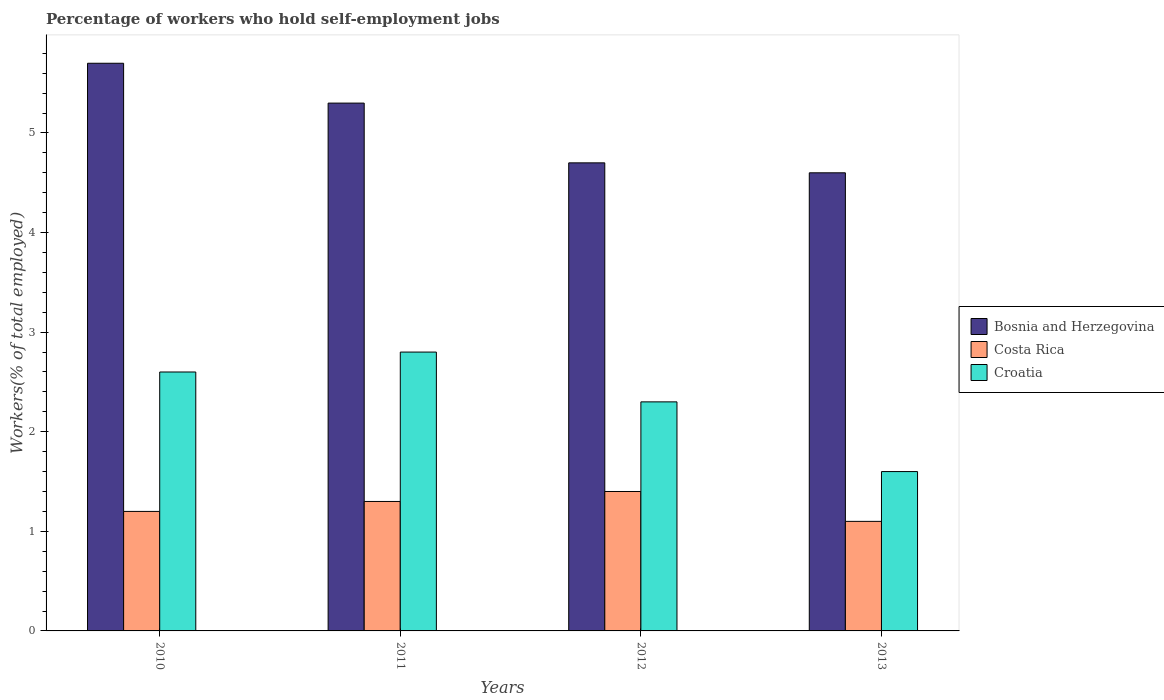How many different coloured bars are there?
Ensure brevity in your answer.  3. Are the number of bars per tick equal to the number of legend labels?
Your response must be concise. Yes. How many bars are there on the 1st tick from the left?
Your answer should be compact. 3. What is the label of the 3rd group of bars from the left?
Keep it short and to the point. 2012. In how many cases, is the number of bars for a given year not equal to the number of legend labels?
Ensure brevity in your answer.  0. What is the percentage of self-employed workers in Bosnia and Herzegovina in 2013?
Give a very brief answer. 4.6. Across all years, what is the maximum percentage of self-employed workers in Croatia?
Make the answer very short. 2.8. Across all years, what is the minimum percentage of self-employed workers in Bosnia and Herzegovina?
Offer a very short reply. 4.6. In which year was the percentage of self-employed workers in Costa Rica maximum?
Keep it short and to the point. 2012. What is the total percentage of self-employed workers in Bosnia and Herzegovina in the graph?
Ensure brevity in your answer.  20.3. What is the difference between the percentage of self-employed workers in Bosnia and Herzegovina in 2010 and that in 2012?
Provide a short and direct response. 1. What is the difference between the percentage of self-employed workers in Bosnia and Herzegovina in 2011 and the percentage of self-employed workers in Croatia in 2013?
Your answer should be very brief. 3.7. What is the average percentage of self-employed workers in Costa Rica per year?
Your answer should be very brief. 1.25. In the year 2011, what is the difference between the percentage of self-employed workers in Croatia and percentage of self-employed workers in Bosnia and Herzegovina?
Offer a very short reply. -2.5. In how many years, is the percentage of self-employed workers in Bosnia and Herzegovina greater than 3 %?
Your response must be concise. 4. What is the ratio of the percentage of self-employed workers in Croatia in 2010 to that in 2013?
Keep it short and to the point. 1.62. Is the difference between the percentage of self-employed workers in Croatia in 2011 and 2012 greater than the difference between the percentage of self-employed workers in Bosnia and Herzegovina in 2011 and 2012?
Your answer should be very brief. No. What is the difference between the highest and the second highest percentage of self-employed workers in Croatia?
Offer a very short reply. 0.2. What is the difference between the highest and the lowest percentage of self-employed workers in Costa Rica?
Keep it short and to the point. 0.3. In how many years, is the percentage of self-employed workers in Croatia greater than the average percentage of self-employed workers in Croatia taken over all years?
Your answer should be compact. 2. Is the sum of the percentage of self-employed workers in Costa Rica in 2011 and 2012 greater than the maximum percentage of self-employed workers in Croatia across all years?
Make the answer very short. No. What does the 3rd bar from the left in 2010 represents?
Your answer should be compact. Croatia. What does the 2nd bar from the right in 2013 represents?
Keep it short and to the point. Costa Rica. How many bars are there?
Your response must be concise. 12. How many years are there in the graph?
Offer a terse response. 4. How are the legend labels stacked?
Your answer should be compact. Vertical. What is the title of the graph?
Make the answer very short. Percentage of workers who hold self-employment jobs. Does "Dominica" appear as one of the legend labels in the graph?
Your response must be concise. No. What is the label or title of the Y-axis?
Give a very brief answer. Workers(% of total employed). What is the Workers(% of total employed) in Bosnia and Herzegovina in 2010?
Offer a very short reply. 5.7. What is the Workers(% of total employed) in Costa Rica in 2010?
Offer a very short reply. 1.2. What is the Workers(% of total employed) in Croatia in 2010?
Ensure brevity in your answer.  2.6. What is the Workers(% of total employed) of Bosnia and Herzegovina in 2011?
Give a very brief answer. 5.3. What is the Workers(% of total employed) of Costa Rica in 2011?
Ensure brevity in your answer.  1.3. What is the Workers(% of total employed) of Croatia in 2011?
Give a very brief answer. 2.8. What is the Workers(% of total employed) of Bosnia and Herzegovina in 2012?
Your response must be concise. 4.7. What is the Workers(% of total employed) of Costa Rica in 2012?
Provide a short and direct response. 1.4. What is the Workers(% of total employed) in Croatia in 2012?
Ensure brevity in your answer.  2.3. What is the Workers(% of total employed) in Bosnia and Herzegovina in 2013?
Offer a terse response. 4.6. What is the Workers(% of total employed) in Costa Rica in 2013?
Offer a very short reply. 1.1. What is the Workers(% of total employed) in Croatia in 2013?
Your answer should be compact. 1.6. Across all years, what is the maximum Workers(% of total employed) in Bosnia and Herzegovina?
Your answer should be compact. 5.7. Across all years, what is the maximum Workers(% of total employed) of Costa Rica?
Your answer should be compact. 1.4. Across all years, what is the maximum Workers(% of total employed) in Croatia?
Keep it short and to the point. 2.8. Across all years, what is the minimum Workers(% of total employed) of Bosnia and Herzegovina?
Offer a terse response. 4.6. Across all years, what is the minimum Workers(% of total employed) of Costa Rica?
Keep it short and to the point. 1.1. Across all years, what is the minimum Workers(% of total employed) of Croatia?
Offer a terse response. 1.6. What is the total Workers(% of total employed) of Bosnia and Herzegovina in the graph?
Your response must be concise. 20.3. What is the difference between the Workers(% of total employed) in Bosnia and Herzegovina in 2010 and that in 2011?
Keep it short and to the point. 0.4. What is the difference between the Workers(% of total employed) of Costa Rica in 2010 and that in 2011?
Offer a very short reply. -0.1. What is the difference between the Workers(% of total employed) of Croatia in 2010 and that in 2011?
Provide a succinct answer. -0.2. What is the difference between the Workers(% of total employed) in Bosnia and Herzegovina in 2010 and that in 2012?
Make the answer very short. 1. What is the difference between the Workers(% of total employed) of Croatia in 2010 and that in 2012?
Provide a succinct answer. 0.3. What is the difference between the Workers(% of total employed) of Costa Rica in 2010 and that in 2013?
Offer a terse response. 0.1. What is the difference between the Workers(% of total employed) of Croatia in 2010 and that in 2013?
Your response must be concise. 1. What is the difference between the Workers(% of total employed) in Bosnia and Herzegovina in 2011 and that in 2013?
Your response must be concise. 0.7. What is the difference between the Workers(% of total employed) in Costa Rica in 2011 and that in 2013?
Ensure brevity in your answer.  0.2. What is the difference between the Workers(% of total employed) in Bosnia and Herzegovina in 2012 and that in 2013?
Your answer should be compact. 0.1. What is the difference between the Workers(% of total employed) in Croatia in 2012 and that in 2013?
Your response must be concise. 0.7. What is the difference between the Workers(% of total employed) of Bosnia and Herzegovina in 2010 and the Workers(% of total employed) of Croatia in 2011?
Keep it short and to the point. 2.9. What is the difference between the Workers(% of total employed) of Costa Rica in 2010 and the Workers(% of total employed) of Croatia in 2011?
Give a very brief answer. -1.6. What is the difference between the Workers(% of total employed) of Bosnia and Herzegovina in 2010 and the Workers(% of total employed) of Costa Rica in 2013?
Your response must be concise. 4.6. What is the difference between the Workers(% of total employed) in Bosnia and Herzegovina in 2010 and the Workers(% of total employed) in Croatia in 2013?
Offer a terse response. 4.1. What is the difference between the Workers(% of total employed) in Bosnia and Herzegovina in 2011 and the Workers(% of total employed) in Croatia in 2012?
Offer a very short reply. 3. What is the difference between the Workers(% of total employed) in Costa Rica in 2011 and the Workers(% of total employed) in Croatia in 2013?
Your answer should be very brief. -0.3. What is the difference between the Workers(% of total employed) of Bosnia and Herzegovina in 2012 and the Workers(% of total employed) of Costa Rica in 2013?
Provide a short and direct response. 3.6. What is the difference between the Workers(% of total employed) of Costa Rica in 2012 and the Workers(% of total employed) of Croatia in 2013?
Make the answer very short. -0.2. What is the average Workers(% of total employed) in Bosnia and Herzegovina per year?
Provide a short and direct response. 5.08. What is the average Workers(% of total employed) of Croatia per year?
Make the answer very short. 2.33. In the year 2011, what is the difference between the Workers(% of total employed) of Bosnia and Herzegovina and Workers(% of total employed) of Costa Rica?
Keep it short and to the point. 4. In the year 2011, what is the difference between the Workers(% of total employed) in Bosnia and Herzegovina and Workers(% of total employed) in Croatia?
Make the answer very short. 2.5. In the year 2012, what is the difference between the Workers(% of total employed) of Bosnia and Herzegovina and Workers(% of total employed) of Costa Rica?
Your answer should be very brief. 3.3. In the year 2012, what is the difference between the Workers(% of total employed) in Bosnia and Herzegovina and Workers(% of total employed) in Croatia?
Provide a succinct answer. 2.4. In the year 2012, what is the difference between the Workers(% of total employed) of Costa Rica and Workers(% of total employed) of Croatia?
Your answer should be very brief. -0.9. In the year 2013, what is the difference between the Workers(% of total employed) of Bosnia and Herzegovina and Workers(% of total employed) of Croatia?
Keep it short and to the point. 3. In the year 2013, what is the difference between the Workers(% of total employed) of Costa Rica and Workers(% of total employed) of Croatia?
Your answer should be very brief. -0.5. What is the ratio of the Workers(% of total employed) of Bosnia and Herzegovina in 2010 to that in 2011?
Your answer should be very brief. 1.08. What is the ratio of the Workers(% of total employed) in Costa Rica in 2010 to that in 2011?
Your response must be concise. 0.92. What is the ratio of the Workers(% of total employed) in Bosnia and Herzegovina in 2010 to that in 2012?
Provide a short and direct response. 1.21. What is the ratio of the Workers(% of total employed) in Costa Rica in 2010 to that in 2012?
Your answer should be very brief. 0.86. What is the ratio of the Workers(% of total employed) in Croatia in 2010 to that in 2012?
Ensure brevity in your answer.  1.13. What is the ratio of the Workers(% of total employed) in Bosnia and Herzegovina in 2010 to that in 2013?
Your response must be concise. 1.24. What is the ratio of the Workers(% of total employed) of Croatia in 2010 to that in 2013?
Make the answer very short. 1.62. What is the ratio of the Workers(% of total employed) in Bosnia and Herzegovina in 2011 to that in 2012?
Keep it short and to the point. 1.13. What is the ratio of the Workers(% of total employed) of Croatia in 2011 to that in 2012?
Your response must be concise. 1.22. What is the ratio of the Workers(% of total employed) in Bosnia and Herzegovina in 2011 to that in 2013?
Your answer should be very brief. 1.15. What is the ratio of the Workers(% of total employed) in Costa Rica in 2011 to that in 2013?
Keep it short and to the point. 1.18. What is the ratio of the Workers(% of total employed) in Bosnia and Herzegovina in 2012 to that in 2013?
Provide a short and direct response. 1.02. What is the ratio of the Workers(% of total employed) of Costa Rica in 2012 to that in 2013?
Your answer should be compact. 1.27. What is the ratio of the Workers(% of total employed) of Croatia in 2012 to that in 2013?
Offer a very short reply. 1.44. What is the difference between the highest and the second highest Workers(% of total employed) in Bosnia and Herzegovina?
Your response must be concise. 0.4. What is the difference between the highest and the second highest Workers(% of total employed) in Costa Rica?
Your answer should be very brief. 0.1. What is the difference between the highest and the lowest Workers(% of total employed) of Bosnia and Herzegovina?
Provide a short and direct response. 1.1. What is the difference between the highest and the lowest Workers(% of total employed) of Croatia?
Provide a short and direct response. 1.2. 